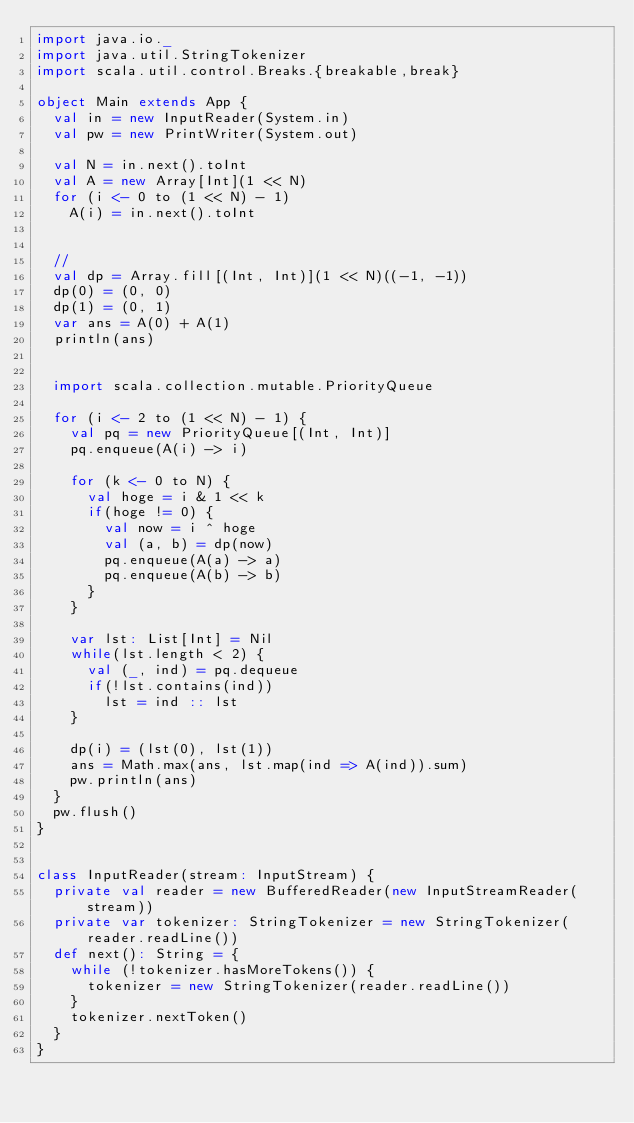<code> <loc_0><loc_0><loc_500><loc_500><_Scala_>import java.io._
import java.util.StringTokenizer
import scala.util.control.Breaks.{breakable,break}

object Main extends App {
  val in = new InputReader(System.in)
  val pw = new PrintWriter(System.out)

  val N = in.next().toInt
  val A = new Array[Int](1 << N)
  for (i <- 0 to (1 << N) - 1)
    A(i) = in.next().toInt


  //
  val dp = Array.fill[(Int, Int)](1 << N)((-1, -1))
  dp(0) = (0, 0)
  dp(1) = (0, 1)
  var ans = A(0) + A(1)
  println(ans)


  import scala.collection.mutable.PriorityQueue

  for (i <- 2 to (1 << N) - 1) {
    val pq = new PriorityQueue[(Int, Int)]
    pq.enqueue(A(i) -> i)

    for (k <- 0 to N) {
      val hoge = i & 1 << k
      if(hoge != 0) {
        val now = i ^ hoge
        val (a, b) = dp(now)
        pq.enqueue(A(a) -> a)
        pq.enqueue(A(b) -> b)
      }
    }

    var lst: List[Int] = Nil
    while(lst.length < 2) {
      val (_, ind) = pq.dequeue
      if(!lst.contains(ind))
        lst = ind :: lst
    }

    dp(i) = (lst(0), lst(1))
    ans = Math.max(ans, lst.map(ind => A(ind)).sum)
    pw.println(ans)
  }
  pw.flush()
}


class InputReader(stream: InputStream) {
  private val reader = new BufferedReader(new InputStreamReader(stream))
  private var tokenizer: StringTokenizer = new StringTokenizer(reader.readLine())
  def next(): String = {
    while (!tokenizer.hasMoreTokens()) {
      tokenizer = new StringTokenizer(reader.readLine())
    }
    tokenizer.nextToken()
  }
}

</code> 